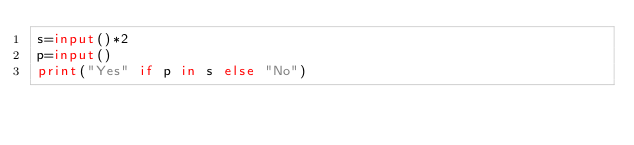Convert code to text. <code><loc_0><loc_0><loc_500><loc_500><_Python_>s=input()*2
p=input()
print("Yes" if p in s else "No")
</code> 